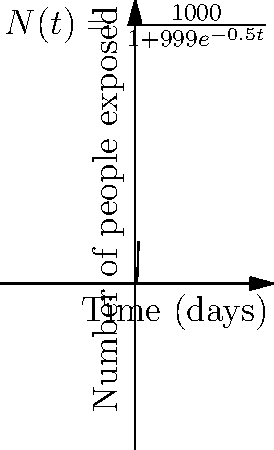As a defense attorney, you're analyzing the spread of alleged hate speech from your client's social media post. The graph shows a logistic model of the number of people exposed to the post over time. The differential equation describing this model is $\frac{dN}{dt} = 0.5N(1-\frac{N}{1000})$, where $N$ is the number of people exposed and $t$ is time in days. What is the approximate number of people exposed to the post after 5 days? To solve this problem, we follow these steps:

1) The solution to the given differential equation is the logistic function:

   $N(t) = \frac{1000}{1+999e^{-0.5t}}$

2) We need to find $N(5)$, i.e., the value of $N$ when $t=5$:

   $N(5) = \frac{1000}{1+999e^{-0.5(5)}}$

3) Let's calculate this step-by-step:
   
   $e^{-0.5(5)} = e^{-2.5} \approx 0.0821$
   
   $999 * 0.0821 \approx 82.0179$
   
   $1 + 82.0179 = 83.0179$
   
   $\frac{1000}{83.0179} \approx 12.0456$

4) Rounding to the nearest whole number (as we're dealing with people):

   $N(5) \approx 12$ people

Therefore, after 5 days, approximately 12 people would have been exposed to the post according to this model.
Answer: 12 people 